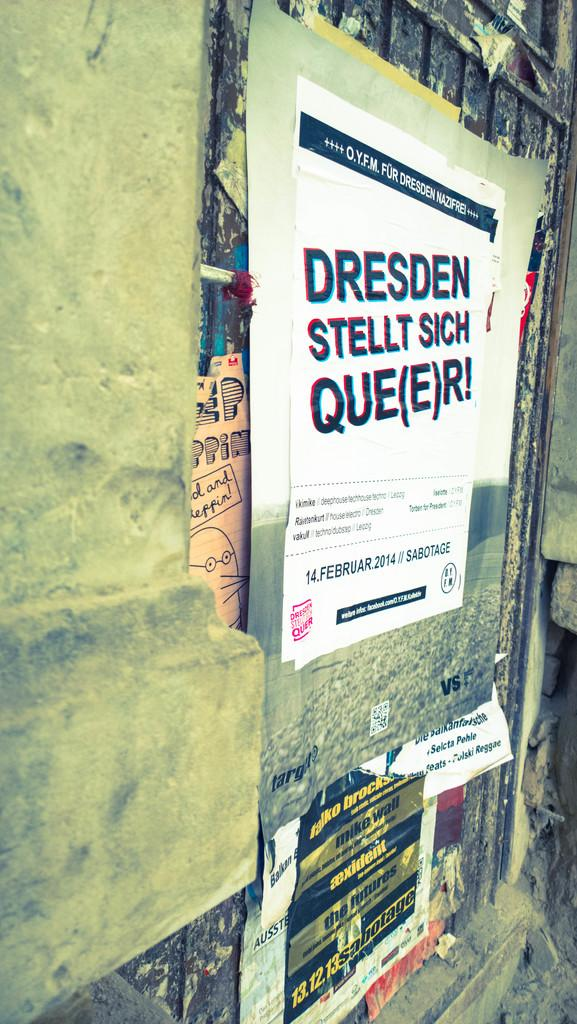<image>
Create a compact narrative representing the image presented. Distressed posters on a building with German writing. 